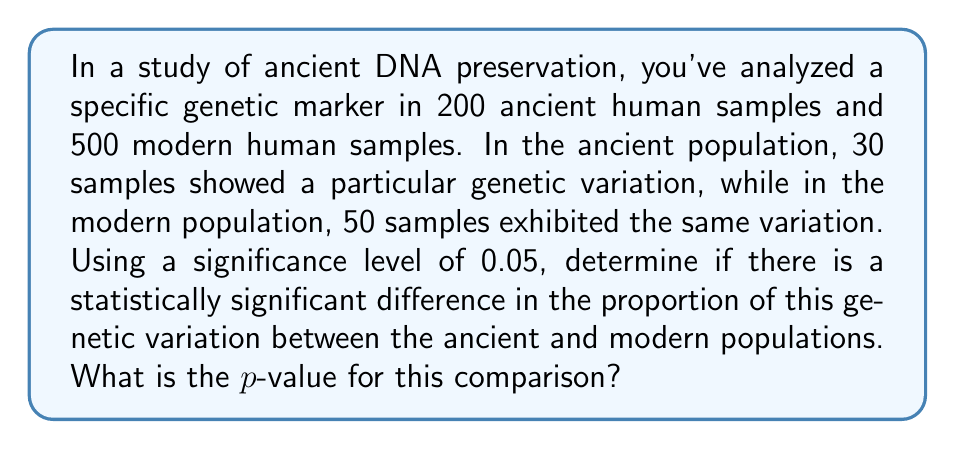Provide a solution to this math problem. To solve this problem, we'll use a two-proportion z-test. Here are the steps:

1. Define our hypotheses:
   $H_0: p_1 = p_2$ (null hypothesis)
   $H_a: p_1 \neq p_2$ (alternative hypothesis)
   Where $p_1$ is the proportion in the ancient population and $p_2$ is the proportion in the modern population.

2. Calculate the sample proportions:
   $\hat{p}_1 = \frac{30}{200} = 0.15$ (ancient)
   $\hat{p}_2 = \frac{50}{500} = 0.10$ (modern)

3. Calculate the pooled proportion:
   $$\hat{p} = \frac{n_1\hat{p}_1 + n_2\hat{p}_2}{n_1 + n_2} = \frac{200(0.15) + 500(0.10)}{200 + 500} = 0.1143$$

4. Calculate the standard error:
   $$SE = \sqrt{\hat{p}(1-\hat{p})(\frac{1}{n_1} + \frac{1}{n_2})} = \sqrt{0.1143(1-0.1143)(\frac{1}{200} + \frac{1}{500})} = 0.0268$$

5. Calculate the z-score:
   $$z = \frac{\hat{p}_1 - \hat{p}_2}{SE} = \frac{0.15 - 0.10}{0.0268} = 1.8657$$

6. Find the p-value:
   For a two-tailed test, p-value $= 2 * P(Z > |z|)$
   Using a standard normal distribution table or calculator:
   p-value $= 2 * P(Z > 1.8657) = 2 * 0.0310 = 0.0620$

The p-value (0.0620) is greater than the significance level (0.05), so we fail to reject the null hypothesis.
Answer: 0.0620 